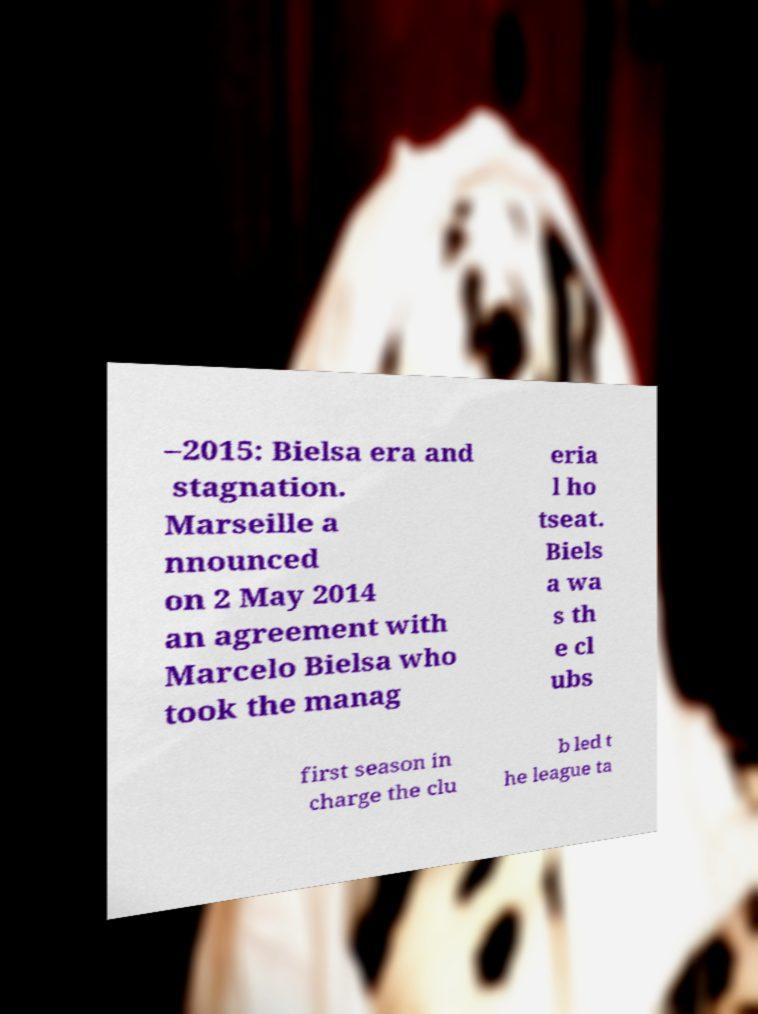Could you extract and type out the text from this image? –2015: Bielsa era and stagnation. Marseille a nnounced on 2 May 2014 an agreement with Marcelo Bielsa who took the manag eria l ho tseat. Biels a wa s th e cl ubs first season in charge the clu b led t he league ta 